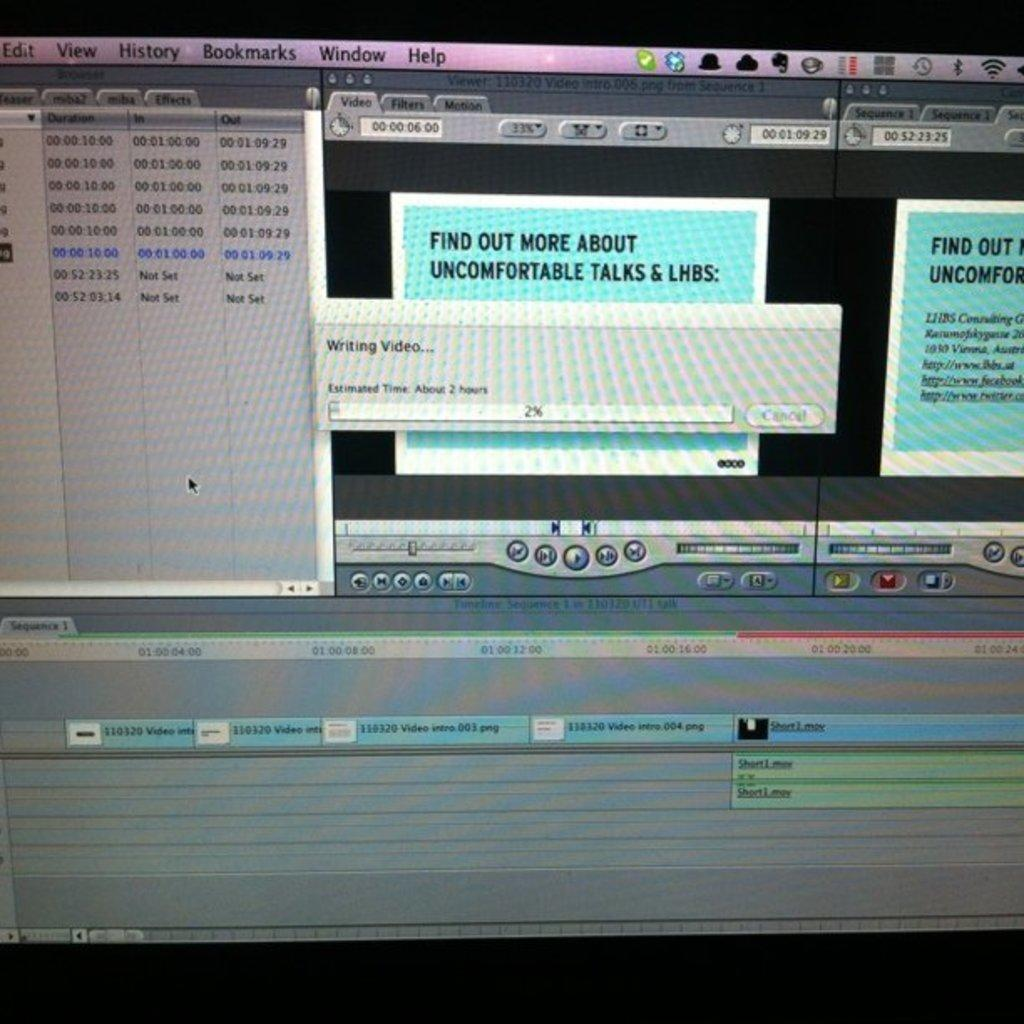<image>
Write a terse but informative summary of the picture. A computer screen with a message that says "find out more about uncomfortable talks & lhbs" 